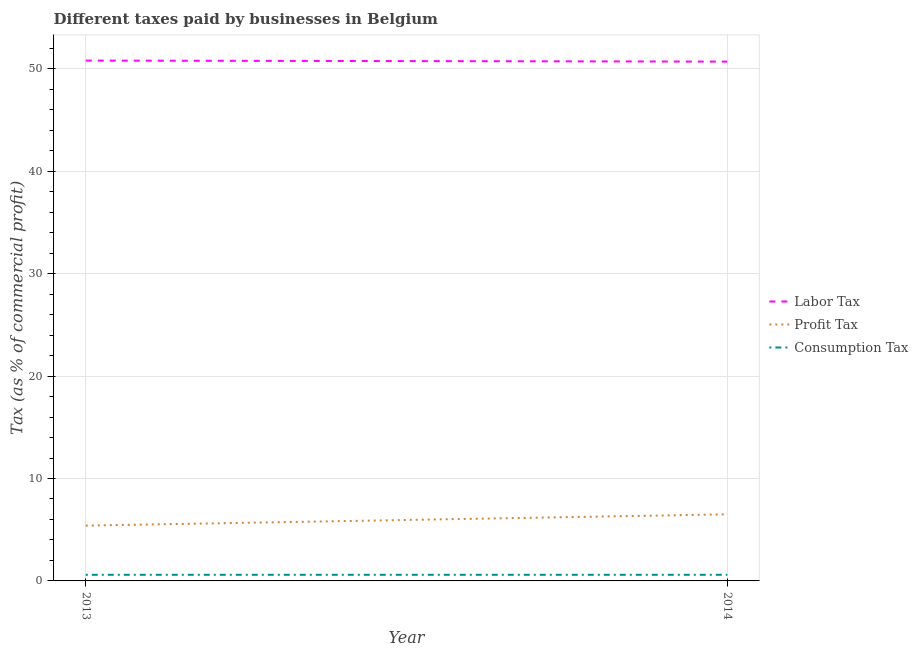How many different coloured lines are there?
Your response must be concise. 3. Is the number of lines equal to the number of legend labels?
Your answer should be compact. Yes. What is the percentage of labor tax in 2013?
Give a very brief answer. 50.8. Across all years, what is the maximum percentage of labor tax?
Offer a very short reply. 50.8. In which year was the percentage of labor tax maximum?
Give a very brief answer. 2013. What is the total percentage of labor tax in the graph?
Your response must be concise. 101.5. What is the difference between the percentage of labor tax in 2013 and that in 2014?
Make the answer very short. 0.1. What is the difference between the percentage of consumption tax in 2013 and the percentage of labor tax in 2014?
Give a very brief answer. -50.1. What is the average percentage of consumption tax per year?
Ensure brevity in your answer.  0.6. In the year 2014, what is the difference between the percentage of profit tax and percentage of labor tax?
Keep it short and to the point. -44.2. In how many years, is the percentage of profit tax greater than 36 %?
Provide a succinct answer. 0. What is the ratio of the percentage of profit tax in 2013 to that in 2014?
Give a very brief answer. 0.83. Is the percentage of profit tax strictly greater than the percentage of labor tax over the years?
Keep it short and to the point. No. Is the percentage of profit tax strictly less than the percentage of consumption tax over the years?
Make the answer very short. No. Are the values on the major ticks of Y-axis written in scientific E-notation?
Make the answer very short. No. How are the legend labels stacked?
Your response must be concise. Vertical. What is the title of the graph?
Make the answer very short. Different taxes paid by businesses in Belgium. Does "Ages 20-60" appear as one of the legend labels in the graph?
Your answer should be compact. No. What is the label or title of the X-axis?
Provide a short and direct response. Year. What is the label or title of the Y-axis?
Provide a succinct answer. Tax (as % of commercial profit). What is the Tax (as % of commercial profit) of Labor Tax in 2013?
Offer a terse response. 50.8. What is the Tax (as % of commercial profit) of Profit Tax in 2013?
Keep it short and to the point. 5.4. What is the Tax (as % of commercial profit) in Consumption Tax in 2013?
Your answer should be very brief. 0.6. What is the Tax (as % of commercial profit) of Labor Tax in 2014?
Your response must be concise. 50.7. What is the Tax (as % of commercial profit) of Profit Tax in 2014?
Provide a succinct answer. 6.5. Across all years, what is the maximum Tax (as % of commercial profit) in Labor Tax?
Give a very brief answer. 50.8. Across all years, what is the maximum Tax (as % of commercial profit) of Consumption Tax?
Ensure brevity in your answer.  0.6. Across all years, what is the minimum Tax (as % of commercial profit) of Labor Tax?
Provide a short and direct response. 50.7. Across all years, what is the minimum Tax (as % of commercial profit) in Profit Tax?
Give a very brief answer. 5.4. Across all years, what is the minimum Tax (as % of commercial profit) of Consumption Tax?
Provide a short and direct response. 0.6. What is the total Tax (as % of commercial profit) in Labor Tax in the graph?
Ensure brevity in your answer.  101.5. What is the total Tax (as % of commercial profit) in Profit Tax in the graph?
Provide a succinct answer. 11.9. What is the total Tax (as % of commercial profit) of Consumption Tax in the graph?
Your answer should be compact. 1.2. What is the difference between the Tax (as % of commercial profit) in Labor Tax in 2013 and that in 2014?
Provide a succinct answer. 0.1. What is the difference between the Tax (as % of commercial profit) in Profit Tax in 2013 and that in 2014?
Your answer should be compact. -1.1. What is the difference between the Tax (as % of commercial profit) in Labor Tax in 2013 and the Tax (as % of commercial profit) in Profit Tax in 2014?
Your response must be concise. 44.3. What is the difference between the Tax (as % of commercial profit) of Labor Tax in 2013 and the Tax (as % of commercial profit) of Consumption Tax in 2014?
Give a very brief answer. 50.2. What is the average Tax (as % of commercial profit) of Labor Tax per year?
Your answer should be compact. 50.75. What is the average Tax (as % of commercial profit) in Profit Tax per year?
Your answer should be compact. 5.95. What is the average Tax (as % of commercial profit) in Consumption Tax per year?
Make the answer very short. 0.6. In the year 2013, what is the difference between the Tax (as % of commercial profit) of Labor Tax and Tax (as % of commercial profit) of Profit Tax?
Your answer should be very brief. 45.4. In the year 2013, what is the difference between the Tax (as % of commercial profit) in Labor Tax and Tax (as % of commercial profit) in Consumption Tax?
Make the answer very short. 50.2. In the year 2013, what is the difference between the Tax (as % of commercial profit) of Profit Tax and Tax (as % of commercial profit) of Consumption Tax?
Offer a terse response. 4.8. In the year 2014, what is the difference between the Tax (as % of commercial profit) in Labor Tax and Tax (as % of commercial profit) in Profit Tax?
Make the answer very short. 44.2. In the year 2014, what is the difference between the Tax (as % of commercial profit) in Labor Tax and Tax (as % of commercial profit) in Consumption Tax?
Make the answer very short. 50.1. In the year 2014, what is the difference between the Tax (as % of commercial profit) in Profit Tax and Tax (as % of commercial profit) in Consumption Tax?
Make the answer very short. 5.9. What is the ratio of the Tax (as % of commercial profit) in Labor Tax in 2013 to that in 2014?
Your answer should be very brief. 1. What is the ratio of the Tax (as % of commercial profit) of Profit Tax in 2013 to that in 2014?
Make the answer very short. 0.83. What is the difference between the highest and the second highest Tax (as % of commercial profit) in Profit Tax?
Your response must be concise. 1.1. 